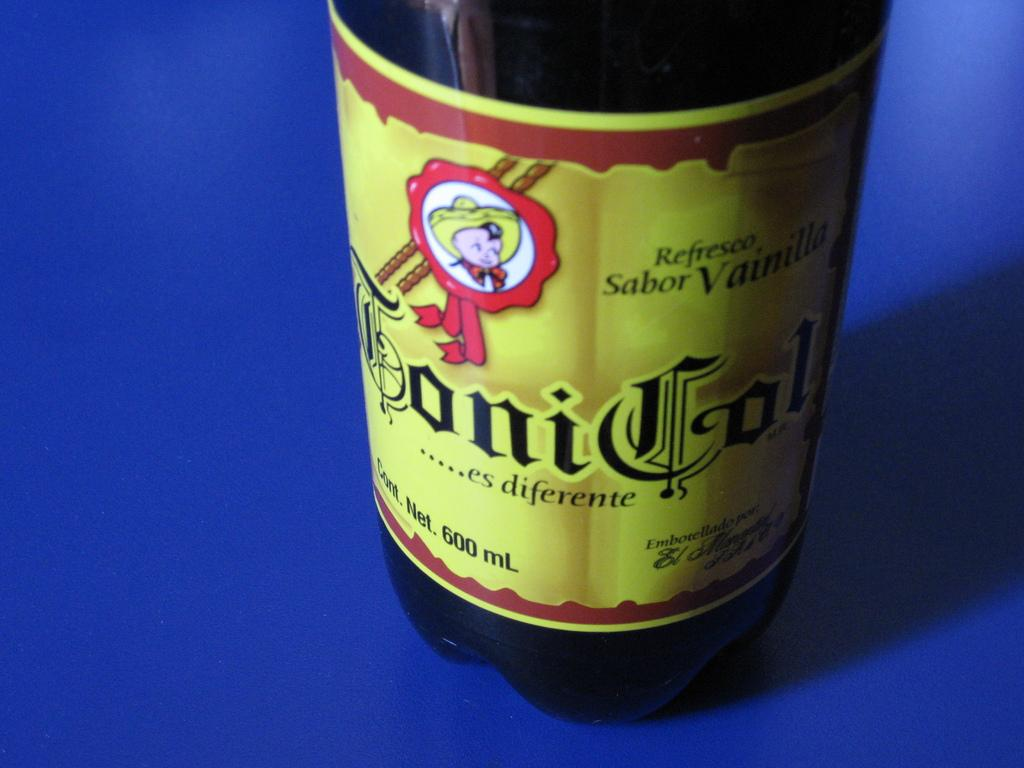<image>
Share a concise interpretation of the image provided. A bottle of a drink that is net 600 ml. 